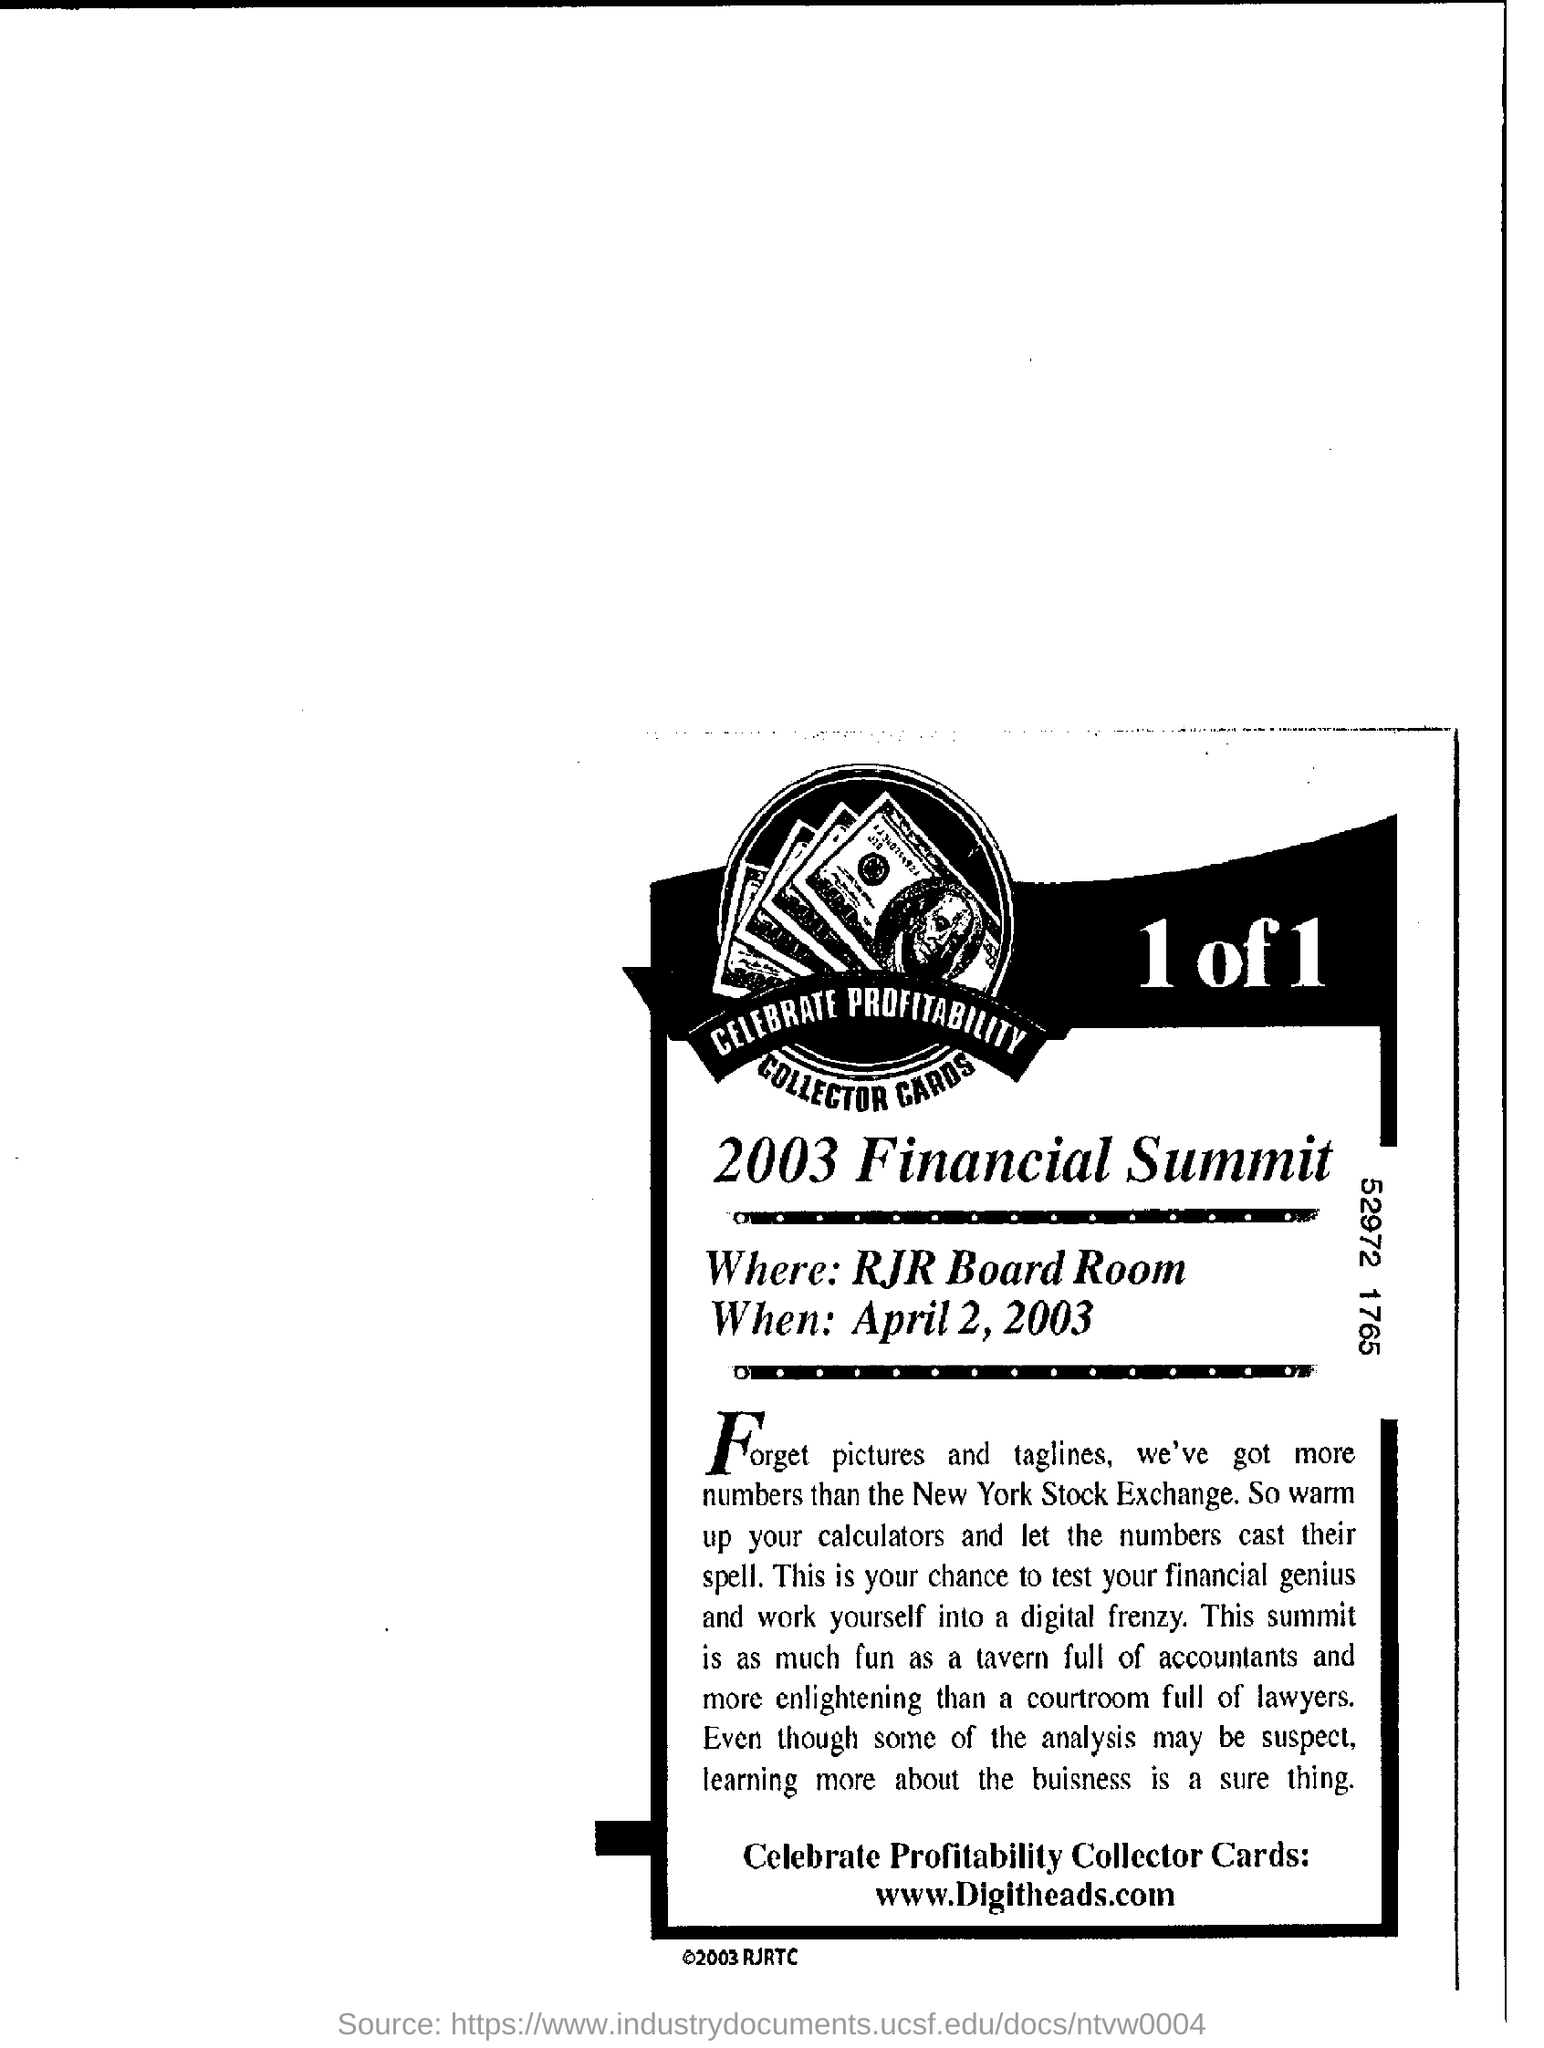Indicate a few pertinent items in this graphic. The name of the summit is the 2003 Financial Summit. The website address provided at the bottom is "<www.Digitheads.com>. The location of the summit is the RJR Board Room. The summit will take place on April 2, 2003. 